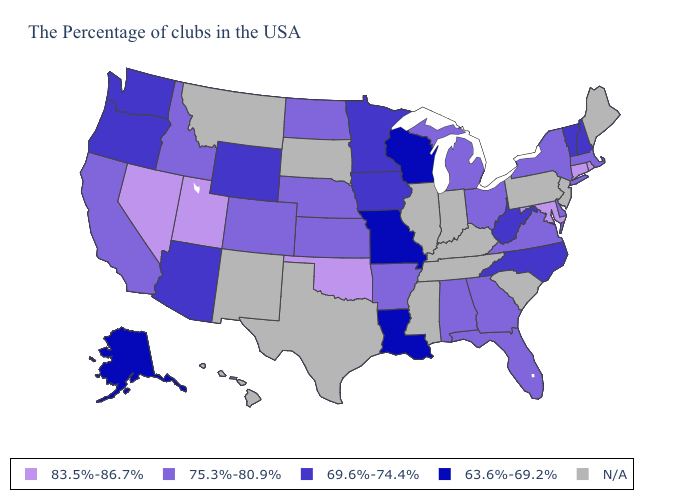Name the states that have a value in the range 83.5%-86.7%?
Concise answer only. Rhode Island, Connecticut, Maryland, Oklahoma, Utah, Nevada. How many symbols are there in the legend?
Answer briefly. 5. What is the lowest value in states that border North Carolina?
Be succinct. 75.3%-80.9%. Does Rhode Island have the highest value in the USA?
Keep it brief. Yes. Name the states that have a value in the range 69.6%-74.4%?
Give a very brief answer. New Hampshire, Vermont, North Carolina, West Virginia, Minnesota, Iowa, Wyoming, Arizona, Washington, Oregon. What is the value of Arkansas?
Keep it brief. 75.3%-80.9%. Among the states that border Nebraska , does Wyoming have the highest value?
Keep it brief. No. Name the states that have a value in the range 63.6%-69.2%?
Write a very short answer. Wisconsin, Louisiana, Missouri, Alaska. Among the states that border Kansas , does Colorado have the highest value?
Give a very brief answer. No. Does the first symbol in the legend represent the smallest category?
Give a very brief answer. No. Which states have the lowest value in the South?
Answer briefly. Louisiana. Does the map have missing data?
Short answer required. Yes. Does the map have missing data?
Answer briefly. Yes. Name the states that have a value in the range 63.6%-69.2%?
Short answer required. Wisconsin, Louisiana, Missouri, Alaska. 